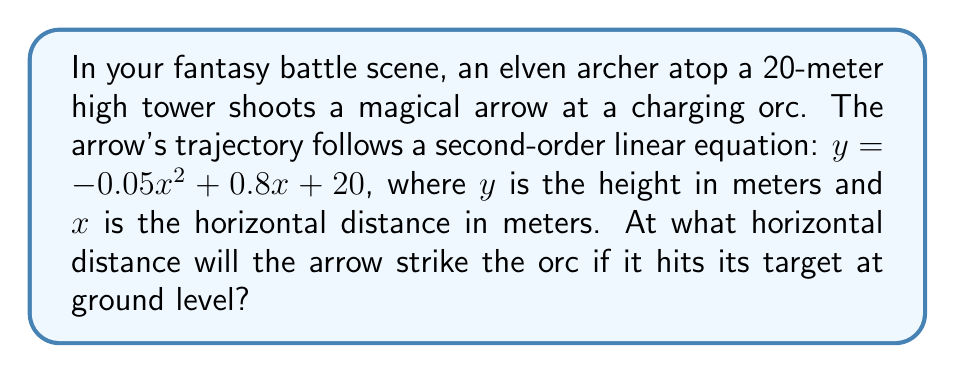Provide a solution to this math problem. To solve this problem, we need to find the positive root of the quadratic equation when $y = 0$ (ground level). Let's approach this step-by-step:

1. Start with the given equation:
   $$y = -0.05x^2 + 0.8x + 20$$

2. Set $y = 0$ to find where the arrow hits the ground:
   $$0 = -0.05x^2 + 0.8x + 20$$

3. Rearrange the equation to standard form $(ax^2 + bx + c = 0)$:
   $$0.05x^2 - 0.8x - 20 = 0$$

4. Use the quadratic formula: $x = \frac{-b \pm \sqrt{b^2 - 4ac}}{2a}$
   Where $a = 0.05$, $b = -0.8$, and $c = -20$

5. Plug these values into the quadratic formula:
   $$x = \frac{0.8 \pm \sqrt{(-0.8)^2 - 4(0.05)(-20)}}{2(0.05)}$$

6. Simplify:
   $$x = \frac{0.8 \pm \sqrt{0.64 + 4}}{0.1} = \frac{0.8 \pm \sqrt{4.64}}{0.1} = \frac{0.8 \pm 2.15}{0.1}$$

7. This gives us two solutions:
   $$x_1 = \frac{0.8 + 2.15}{0.1} = 29.5$$
   $$x_2 = \frac{0.8 - 2.15}{0.1} = -13.5$$

8. Since we're looking for the distance the arrow travels forward, we take the positive solution.

Therefore, the arrow will strike the orc at a horizontal distance of 29.5 meters from the base of the tower.
Answer: 29.5 meters 